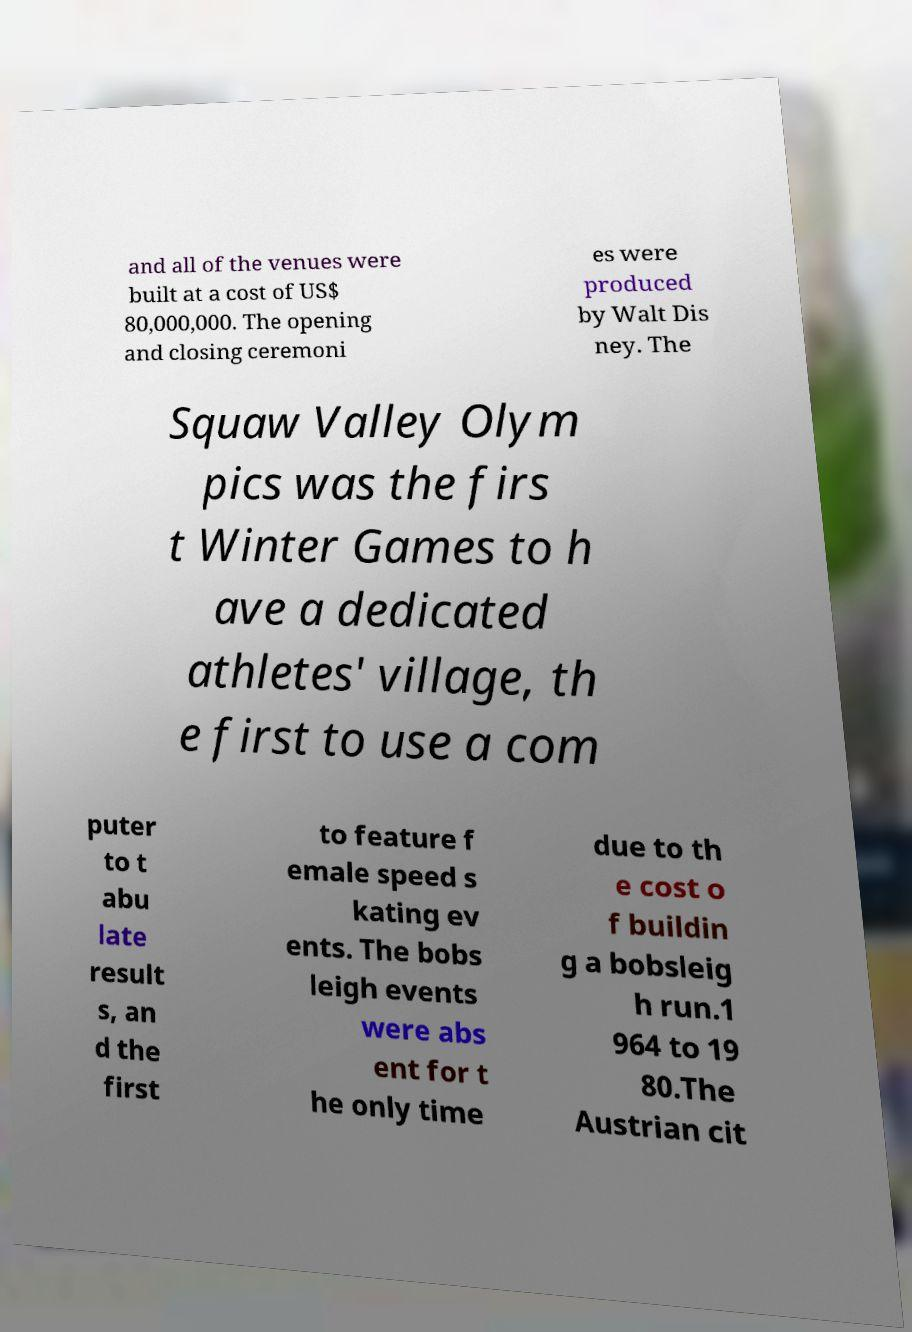Can you read and provide the text displayed in the image?This photo seems to have some interesting text. Can you extract and type it out for me? and all of the venues were built at a cost of US$ 80,000,000. The opening and closing ceremoni es were produced by Walt Dis ney. The Squaw Valley Olym pics was the firs t Winter Games to h ave a dedicated athletes' village, th e first to use a com puter to t abu late result s, an d the first to feature f emale speed s kating ev ents. The bobs leigh events were abs ent for t he only time due to th e cost o f buildin g a bobsleig h run.1 964 to 19 80.The Austrian cit 